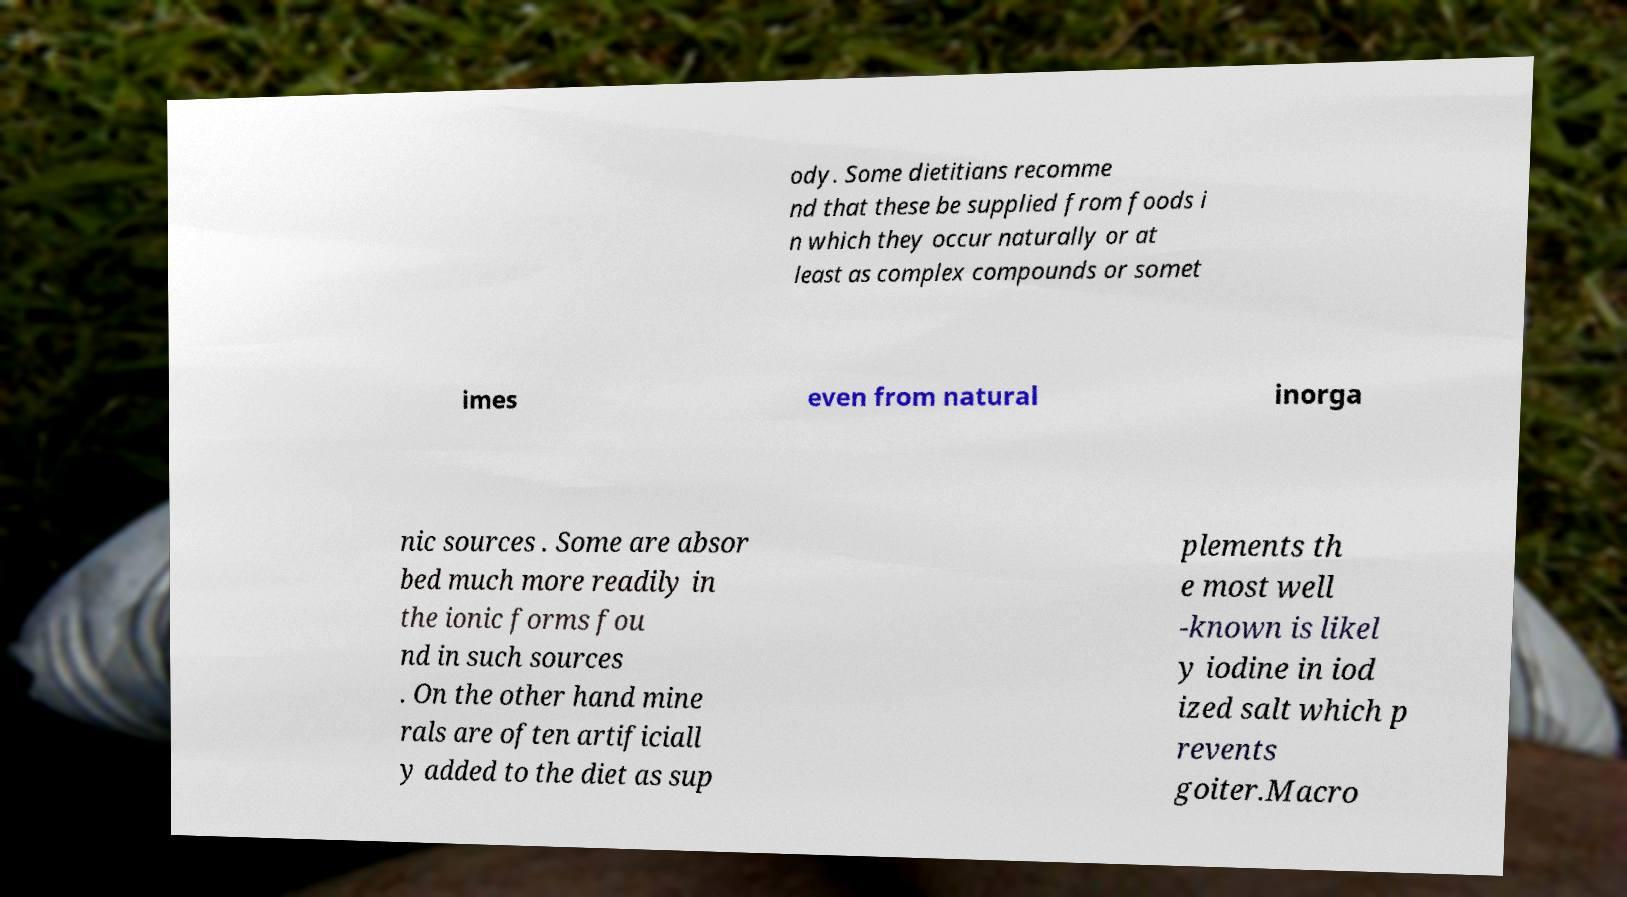What messages or text are displayed in this image? I need them in a readable, typed format. ody. Some dietitians recomme nd that these be supplied from foods i n which they occur naturally or at least as complex compounds or somet imes even from natural inorga nic sources . Some are absor bed much more readily in the ionic forms fou nd in such sources . On the other hand mine rals are often artificiall y added to the diet as sup plements th e most well -known is likel y iodine in iod ized salt which p revents goiter.Macro 